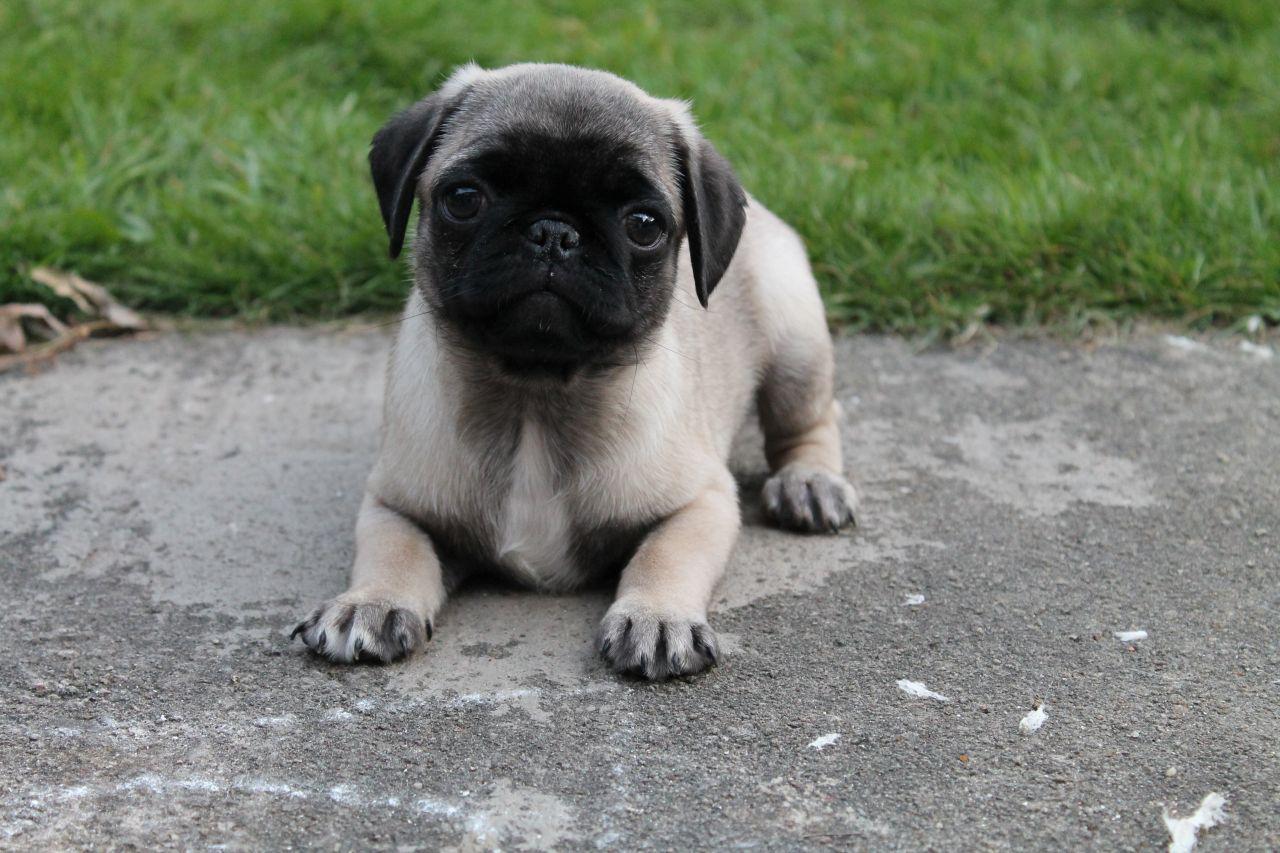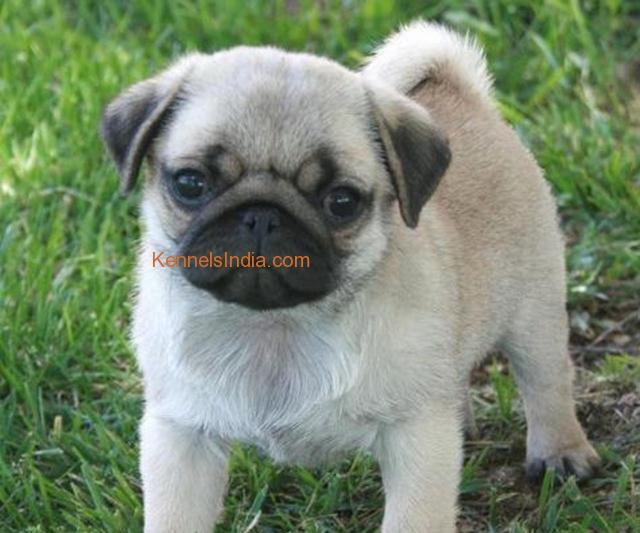The first image is the image on the left, the second image is the image on the right. For the images displayed, is the sentence "Exactly one dog is in the grass." factually correct? Answer yes or no. Yes. The first image is the image on the left, the second image is the image on the right. Analyze the images presented: Is the assertion "Each image shows one pug posed outdoors, and one image shows a standing pug while the other shows a reclining pug." valid? Answer yes or no. Yes. 